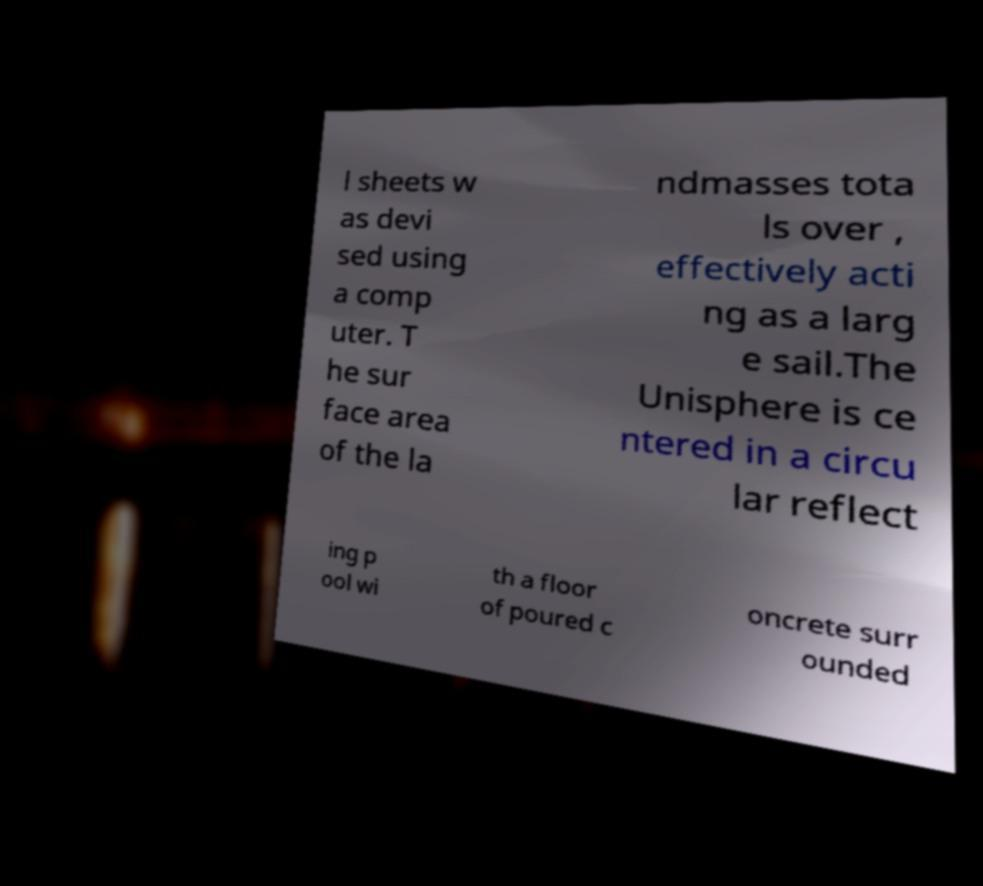Can you read and provide the text displayed in the image?This photo seems to have some interesting text. Can you extract and type it out for me? l sheets w as devi sed using a comp uter. T he sur face area of the la ndmasses tota ls over , effectively acti ng as a larg e sail.The Unisphere is ce ntered in a circu lar reflect ing p ool wi th a floor of poured c oncrete surr ounded 